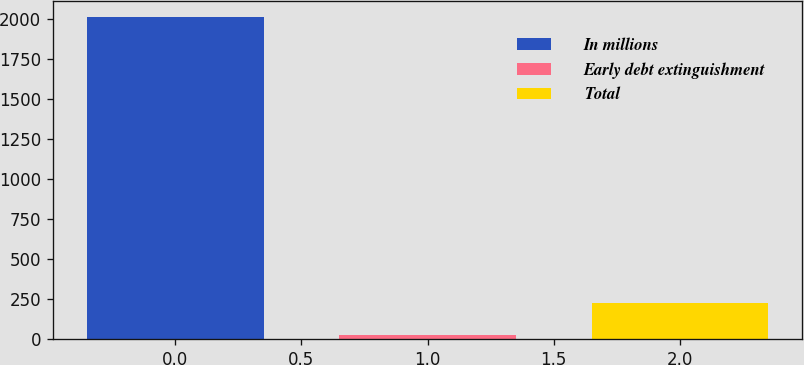Convert chart to OTSL. <chart><loc_0><loc_0><loc_500><loc_500><bar_chart><fcel>In millions<fcel>Early debt extinguishment<fcel>Total<nl><fcel>2016<fcel>29<fcel>227.7<nl></chart> 